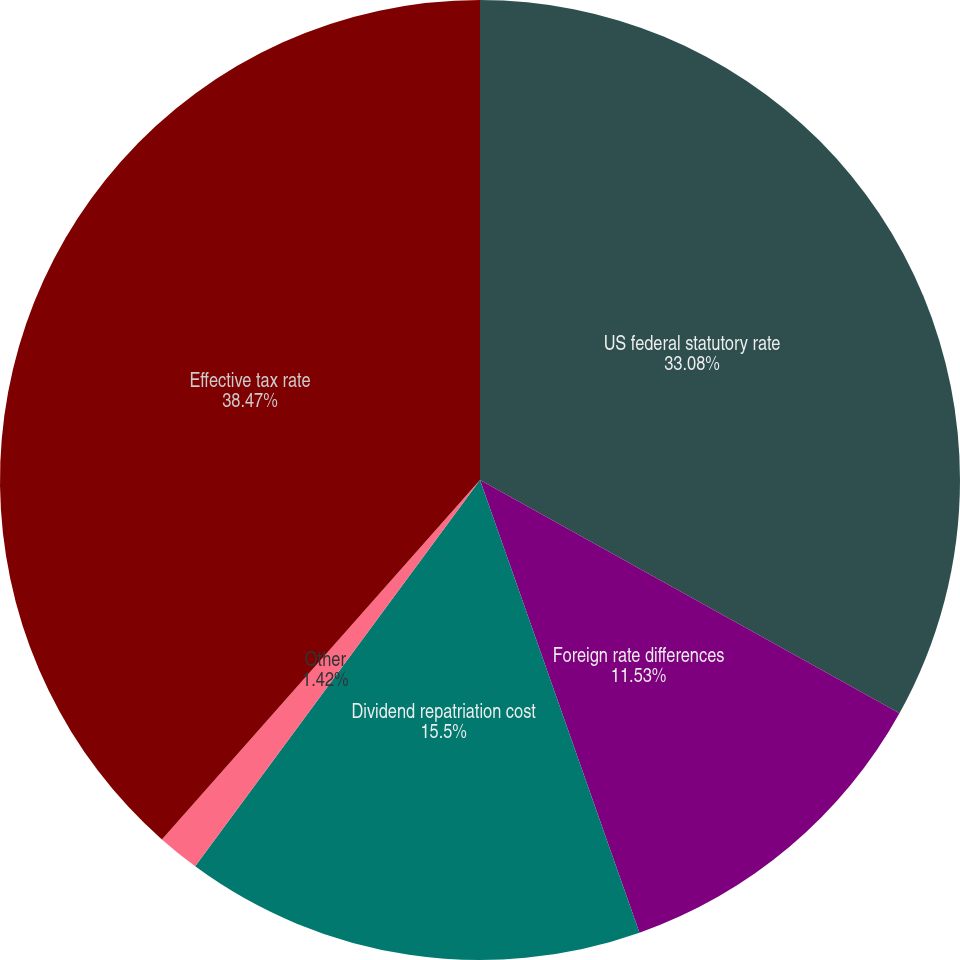Convert chart to OTSL. <chart><loc_0><loc_0><loc_500><loc_500><pie_chart><fcel>US federal statutory rate<fcel>Foreign rate differences<fcel>Dividend repatriation cost<fcel>Other<fcel>Effective tax rate<nl><fcel>33.08%<fcel>11.53%<fcel>15.5%<fcel>1.42%<fcel>38.47%<nl></chart> 